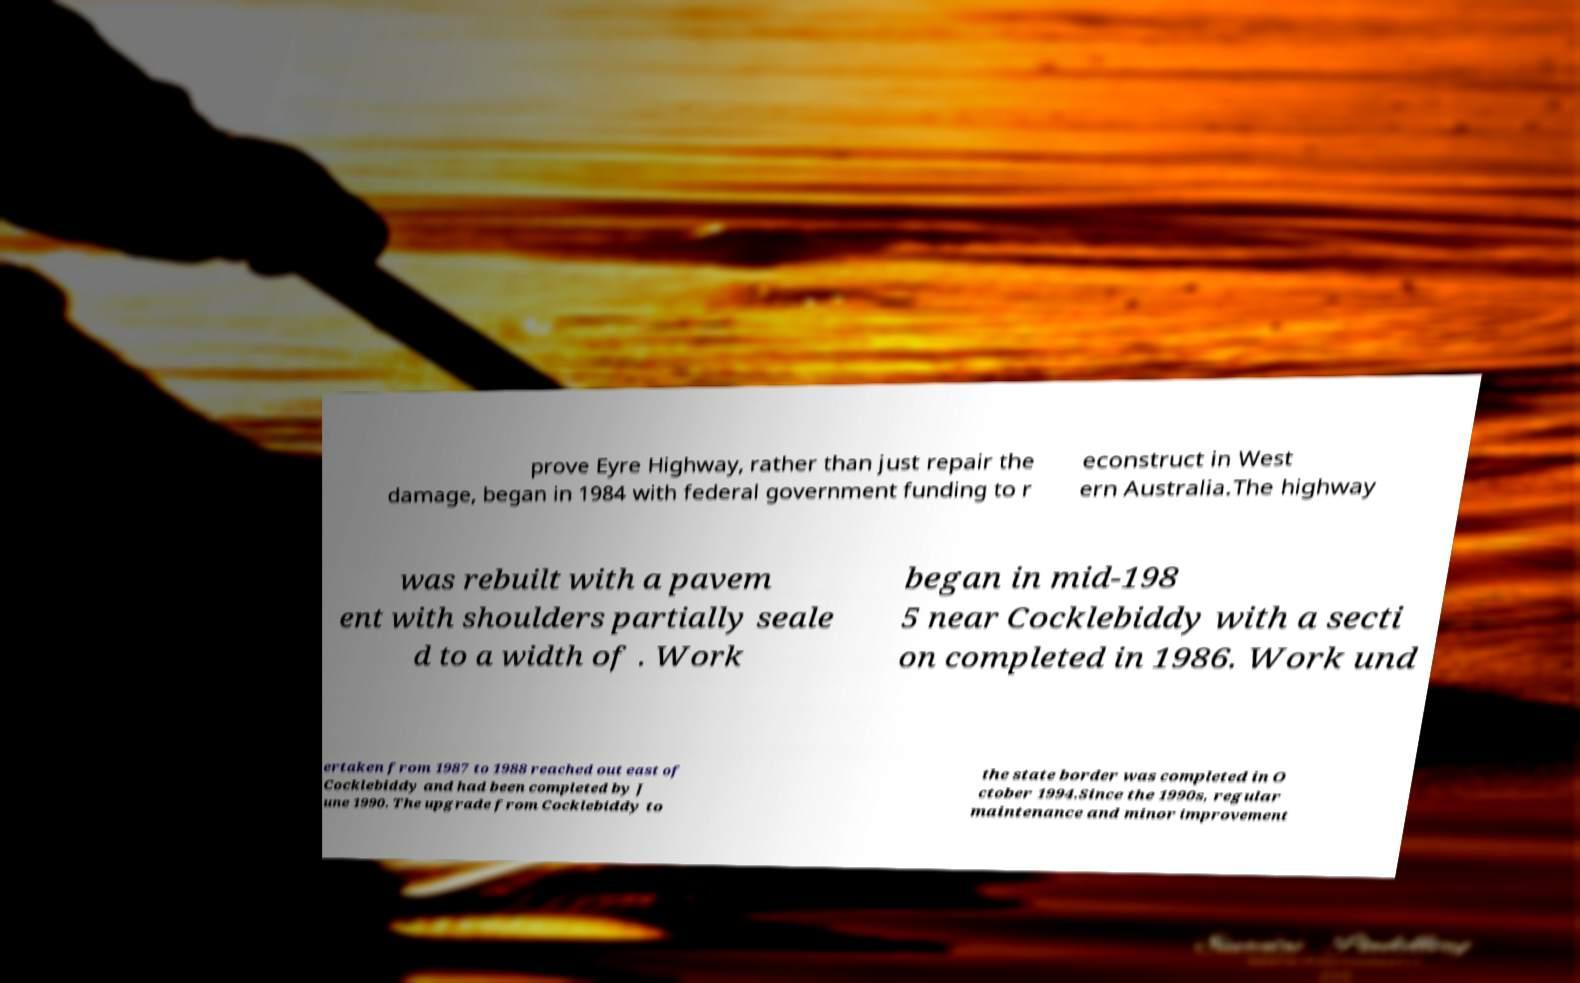I need the written content from this picture converted into text. Can you do that? prove Eyre Highway, rather than just repair the damage, began in 1984 with federal government funding to r econstruct in West ern Australia.The highway was rebuilt with a pavem ent with shoulders partially seale d to a width of . Work began in mid-198 5 near Cocklebiddy with a secti on completed in 1986. Work und ertaken from 1987 to 1988 reached out east of Cocklebiddy and had been completed by J une 1990. The upgrade from Cocklebiddy to the state border was completed in O ctober 1994.Since the 1990s, regular maintenance and minor improvement 